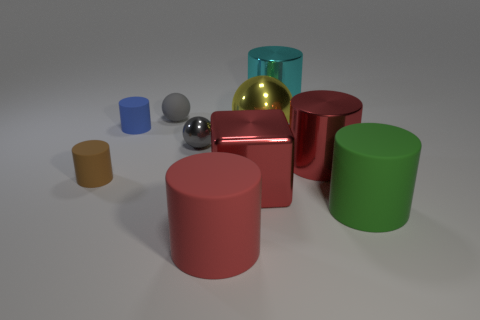Subtract all large yellow metal spheres. How many spheres are left? 2 Subtract all brown cylinders. How many cylinders are left? 5 Subtract all spheres. How many objects are left? 7 Subtract 4 cylinders. How many cylinders are left? 2 Subtract all cyan blocks. Subtract all purple cylinders. How many blocks are left? 1 Subtract all yellow blocks. How many green cylinders are left? 1 Subtract all yellow matte blocks. Subtract all tiny gray matte objects. How many objects are left? 9 Add 2 red rubber cylinders. How many red rubber cylinders are left? 3 Add 4 large green rubber cylinders. How many large green rubber cylinders exist? 5 Subtract 1 cyan cylinders. How many objects are left? 9 